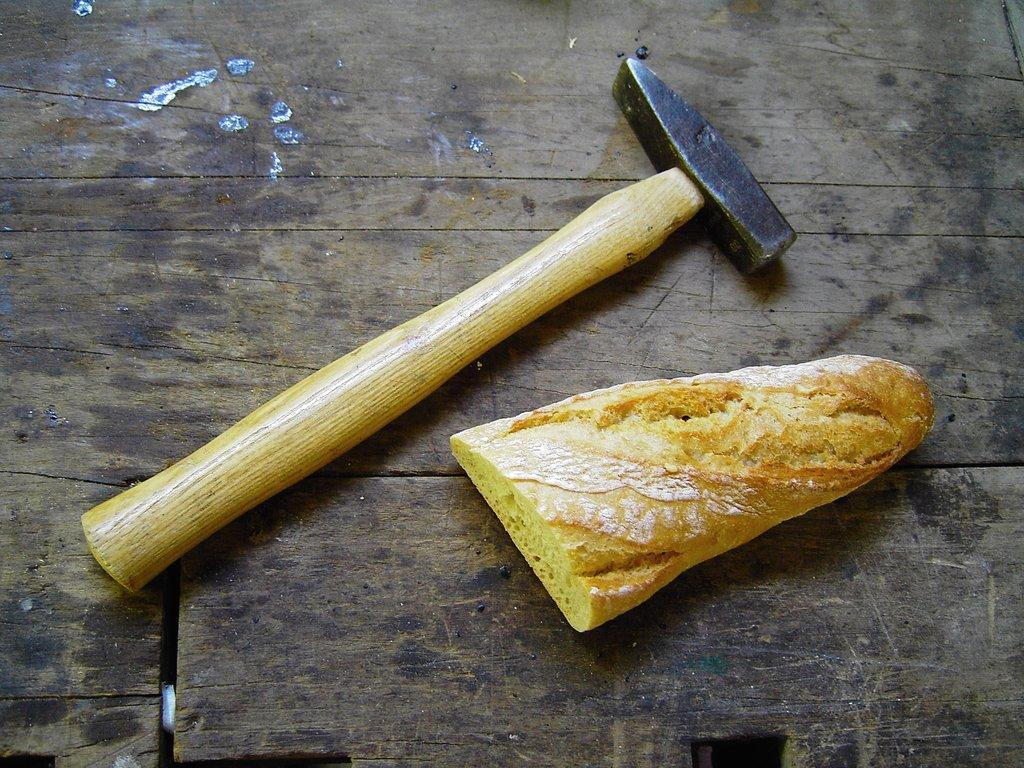What tool is visible in the image? There is a hammer in the image. What else can be seen in the image besides the hammer? There is a food item in the image. Where are the hammer and food item located? The hammer and food item are on a wooden platform. How many houses are visible in the image? There are no houses visible in the image. What type of trouble is the hammer causing in the image? The hammer is not causing any trouble in the image; it is simply a tool on a wooden platform. 